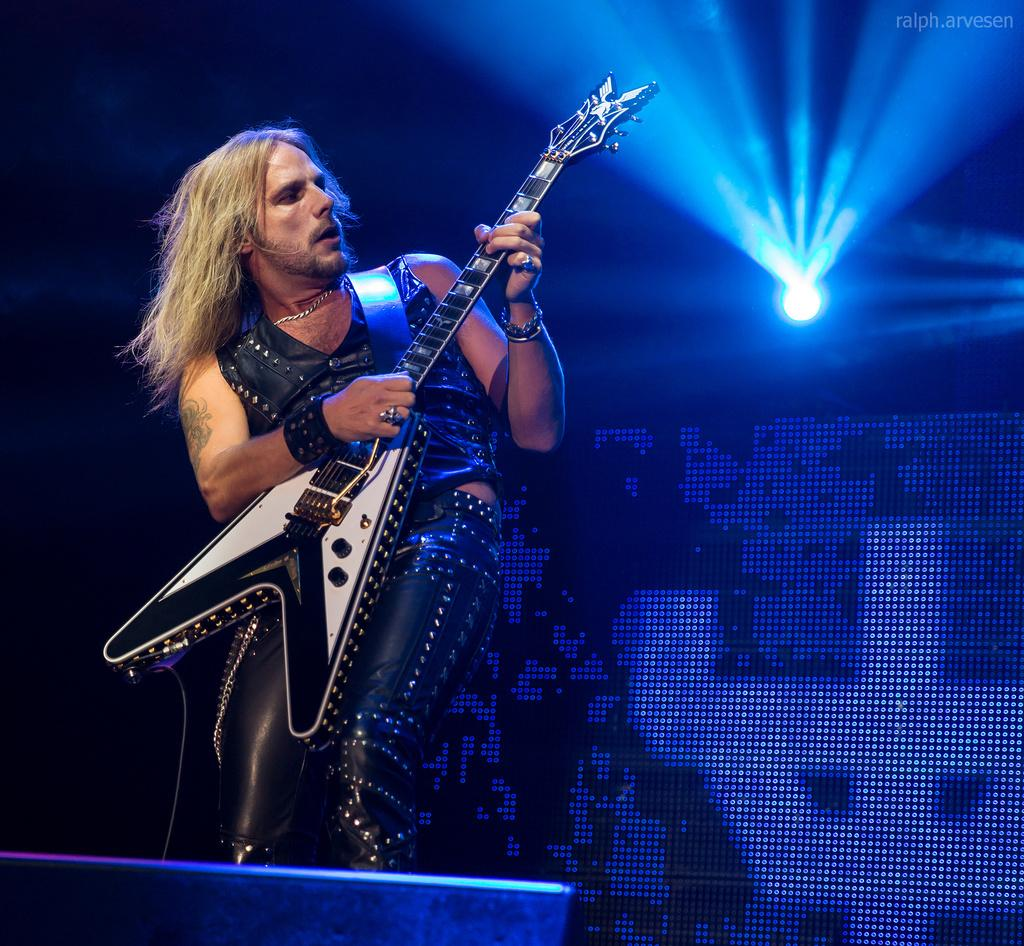Who is present in the image? There is a person in the image. What is the person holding? The person is holding a guitar. What can be seen in the background of the image? There is a screen in the background of the image. Can you describe the lighting in the image? There is a light in the image. What month is it in the image? The month is not mentioned or depicted in the image, so it cannot be determined. 